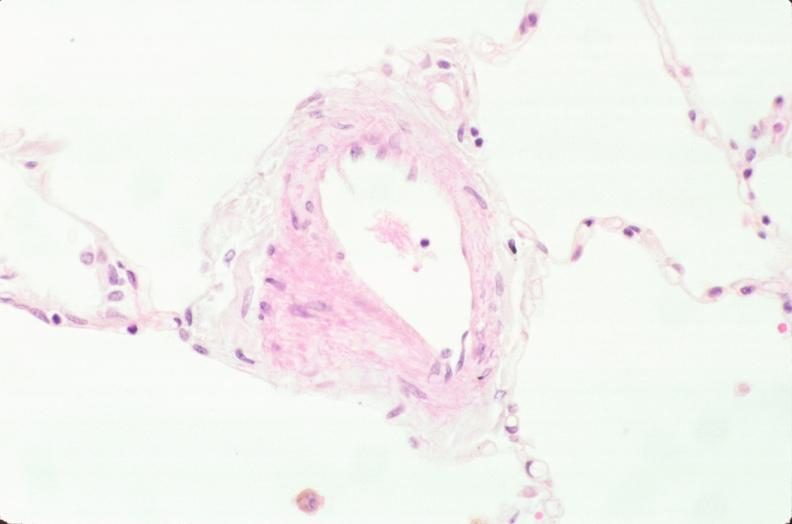what is present?
Answer the question using a single word or phrase. Respiratory 